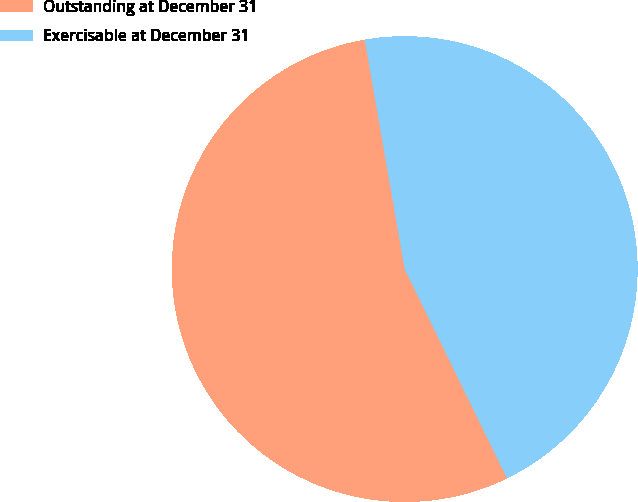Convert chart. <chart><loc_0><loc_0><loc_500><loc_500><pie_chart><fcel>Outstanding at December 31<fcel>Exercisable at December 31<nl><fcel>54.5%<fcel>45.5%<nl></chart> 